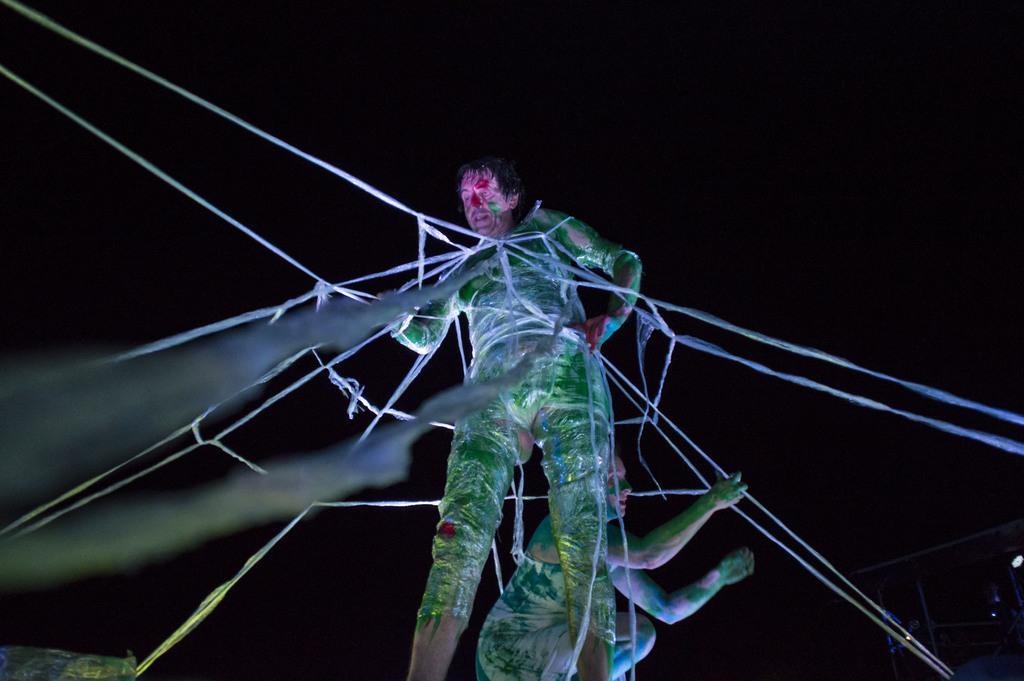Describe this image in one or two sentences. In this image we can see a person tied with ropes and the other person is holding the ropes, also we can see the background is dark. 